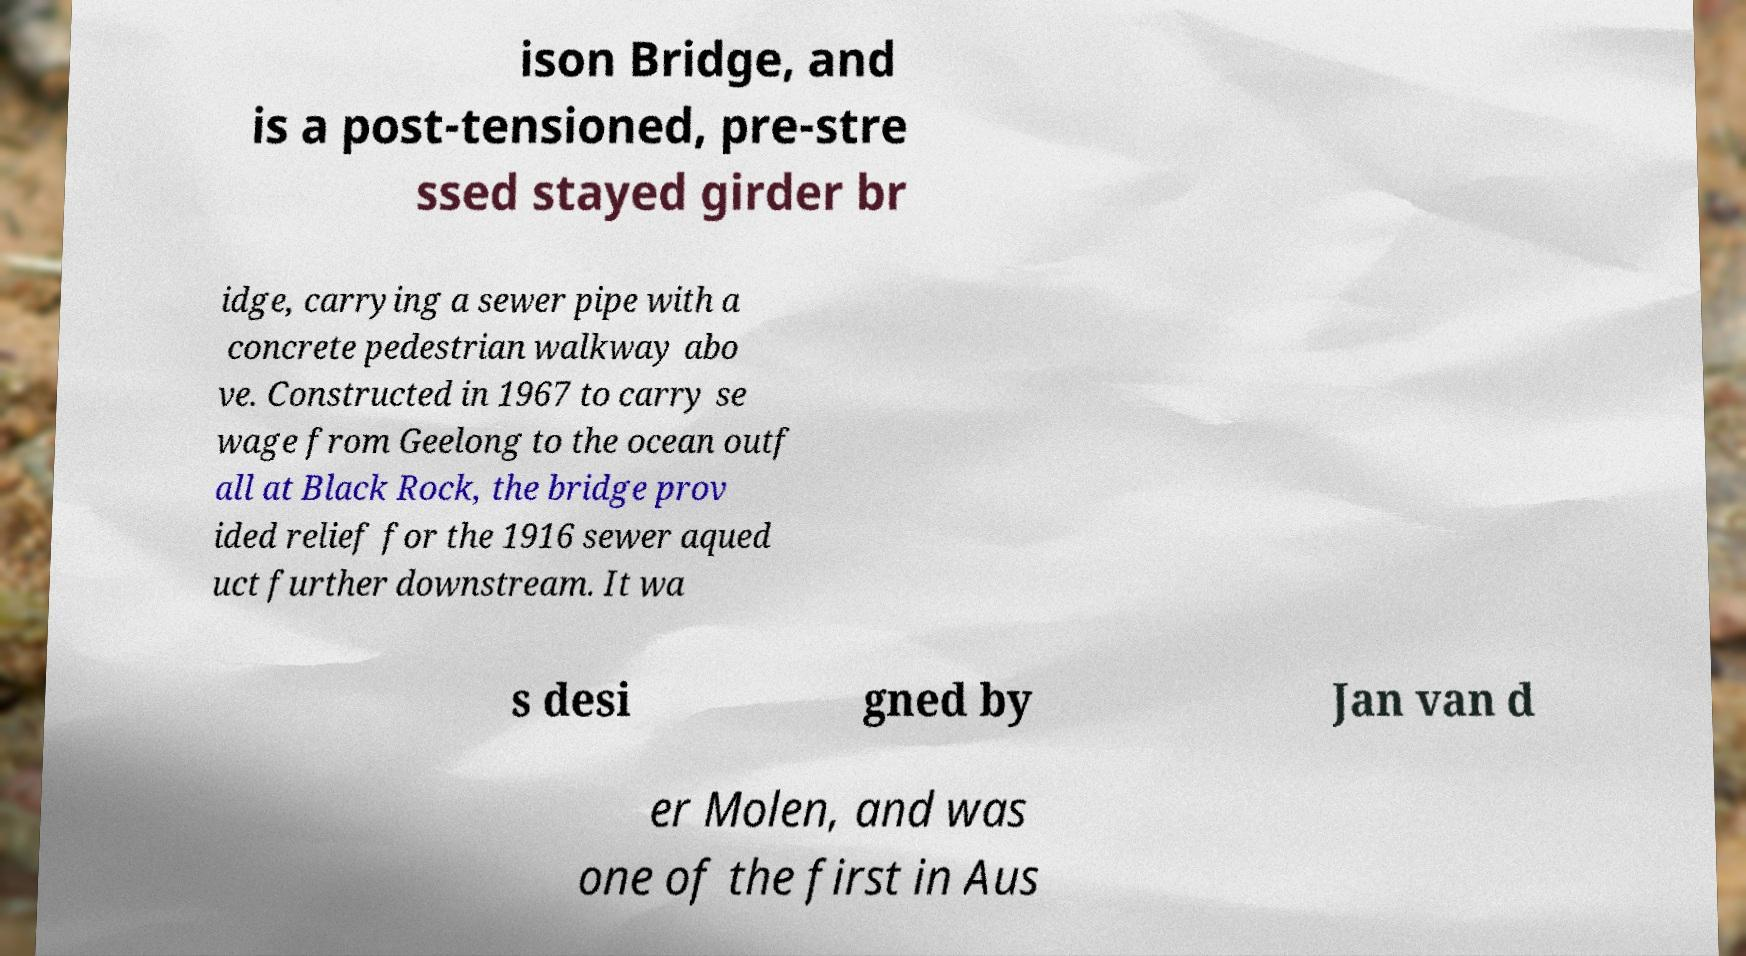Please identify and transcribe the text found in this image. ison Bridge, and is a post-tensioned, pre-stre ssed stayed girder br idge, carrying a sewer pipe with a concrete pedestrian walkway abo ve. Constructed in 1967 to carry se wage from Geelong to the ocean outf all at Black Rock, the bridge prov ided relief for the 1916 sewer aqued uct further downstream. It wa s desi gned by Jan van d er Molen, and was one of the first in Aus 